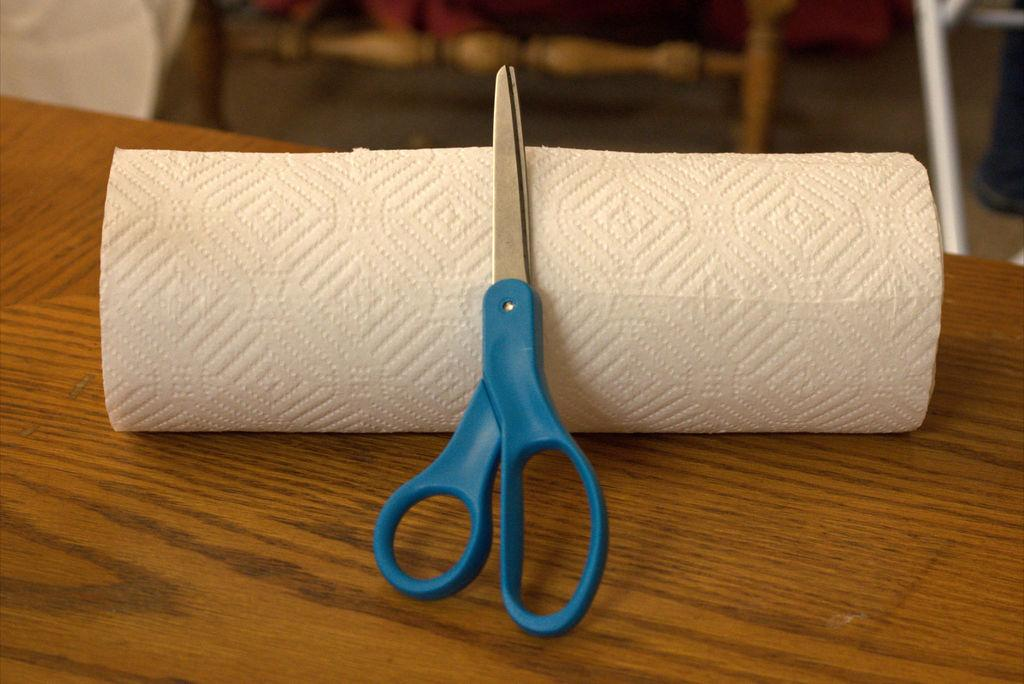What type of tool is visible in the image? There are scissors in the image. What material is present alongside the scissors? There is paper in the image. Where are the scissors and paper located? The scissors and paper are placed on a table. What type of veil is being used to play with the notebook in the image? There is no veil or notebook present in the image; it only features scissors and paper on a table. 